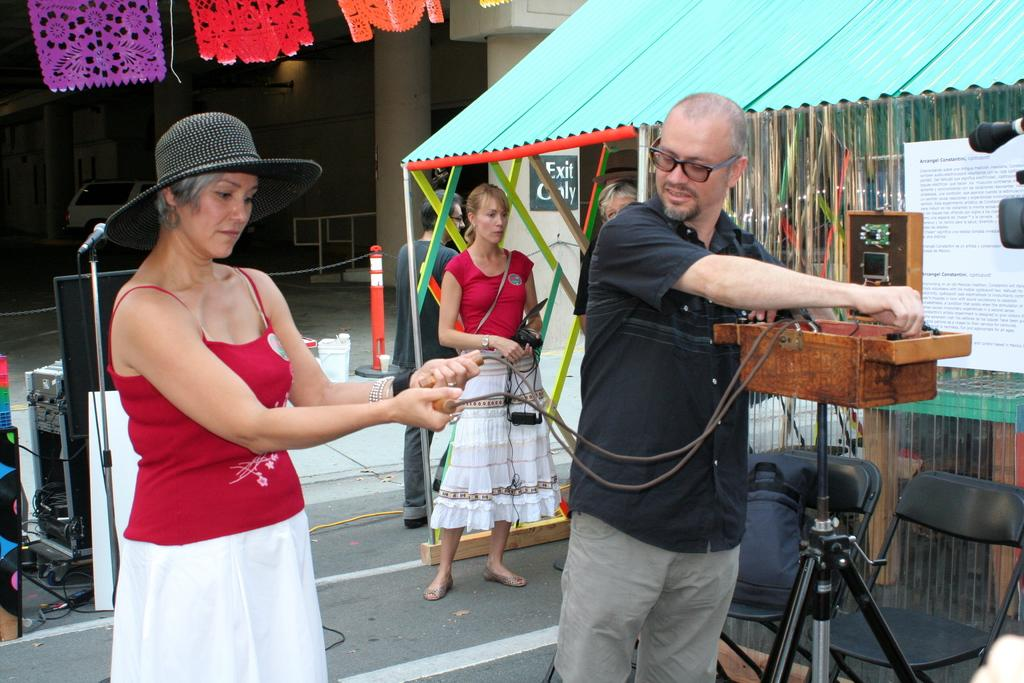Who are the two people standing in the image? There is a man and a woman standing in the image. Are there any other people visible in the image? Yes, there are people standing in the background of the image. What type of structure can be seen in the image? There is a shed visible in the image. What street is the man and woman standing on in the image? There is no street visible in the image; it only shows the man, the woman, and the people in the background. 